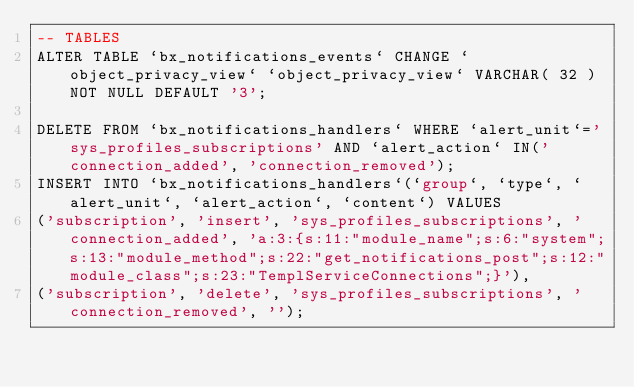Convert code to text. <code><loc_0><loc_0><loc_500><loc_500><_SQL_>-- TABLES
ALTER TABLE `bx_notifications_events` CHANGE `object_privacy_view` `object_privacy_view` VARCHAR( 32 ) NOT NULL DEFAULT '3';

DELETE FROM `bx_notifications_handlers` WHERE `alert_unit`='sys_profiles_subscriptions' AND `alert_action` IN('connection_added', 'connection_removed');
INSERT INTO `bx_notifications_handlers`(`group`, `type`, `alert_unit`, `alert_action`, `content`) VALUES
('subscription', 'insert', 'sys_profiles_subscriptions', 'connection_added', 'a:3:{s:11:"module_name";s:6:"system";s:13:"module_method";s:22:"get_notifications_post";s:12:"module_class";s:23:"TemplServiceConnections";}'),
('subscription', 'delete', 'sys_profiles_subscriptions', 'connection_removed', '');</code> 